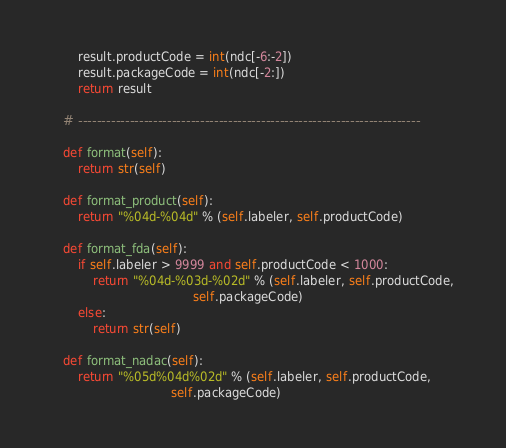Convert code to text. <code><loc_0><loc_0><loc_500><loc_500><_Python_>        result.productCode = int(ndc[-6:-2])
        result.packageCode = int(ndc[-2:])
        return result

    # -------------------------------------------------------------------------

    def format(self):
        return str(self)   

    def format_product(self):
        return "%04d-%04d" % (self.labeler, self.productCode)

    def format_fda(self):
        if self.labeler > 9999 and self.productCode < 1000:
            return "%04d-%03d-%02d" % (self.labeler, self.productCode, 
                                       self.packageCode)
        else:
            return str(self)

    def format_nadac(self):
        return "%05d%04d%02d" % (self.labeler, self.productCode, 
                                 self.packageCode)
</code> 